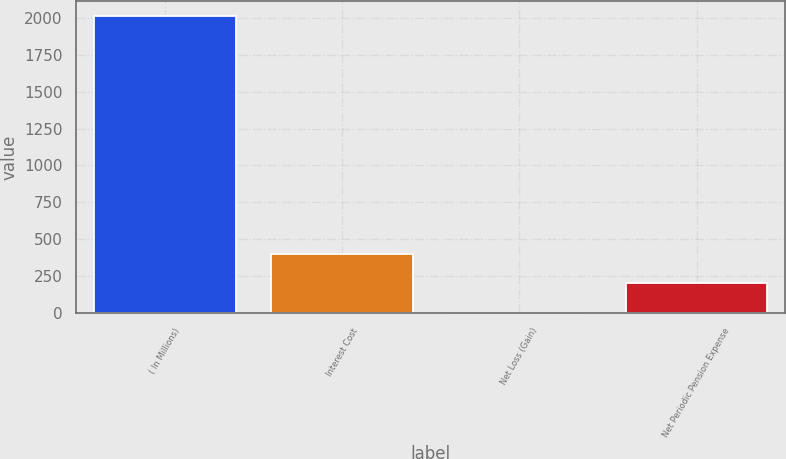Convert chart. <chart><loc_0><loc_0><loc_500><loc_500><bar_chart><fcel>( In Millions)<fcel>Interest Cost<fcel>Net Loss (Gain)<fcel>Net Periodic Pension Expense<nl><fcel>2013<fcel>403.4<fcel>1<fcel>202.2<nl></chart> 